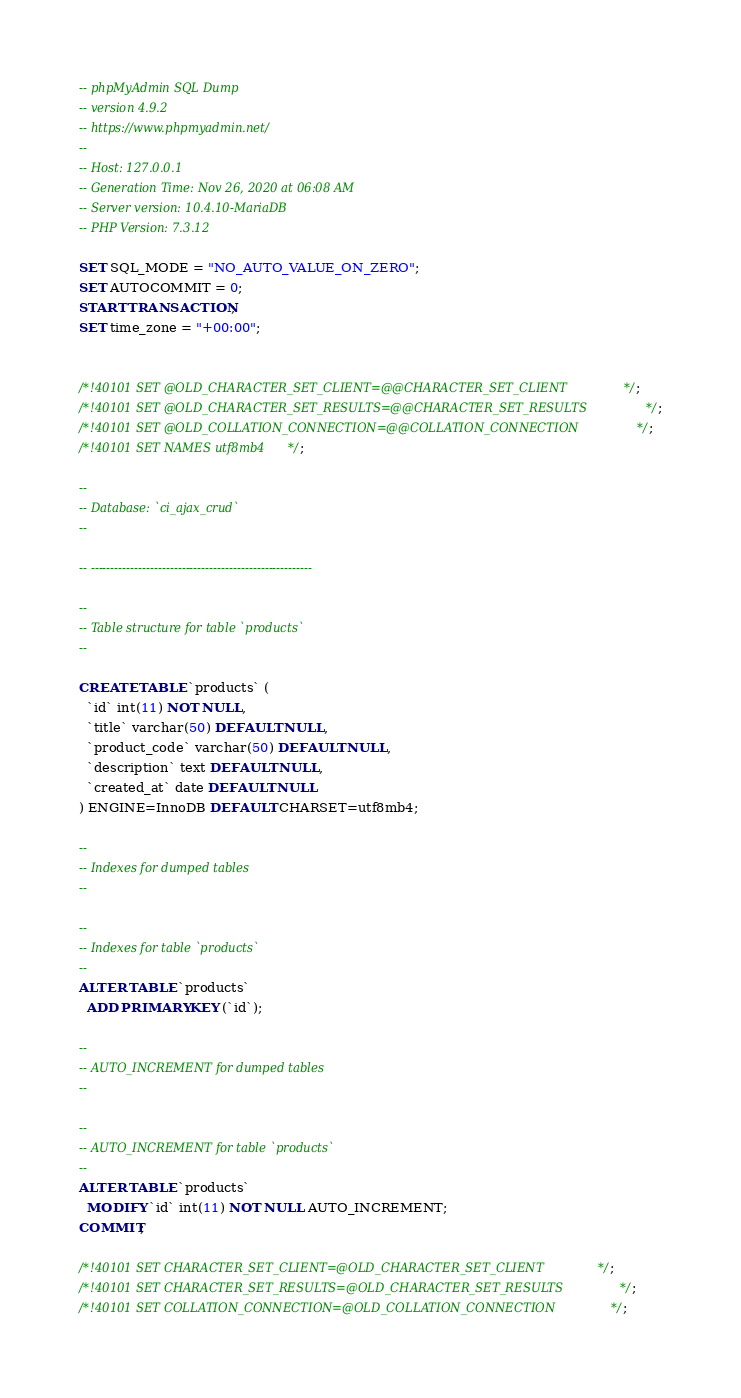Convert code to text. <code><loc_0><loc_0><loc_500><loc_500><_SQL_>-- phpMyAdmin SQL Dump
-- version 4.9.2
-- https://www.phpmyadmin.net/
--
-- Host: 127.0.0.1
-- Generation Time: Nov 26, 2020 at 06:08 AM
-- Server version: 10.4.10-MariaDB
-- PHP Version: 7.3.12

SET SQL_MODE = "NO_AUTO_VALUE_ON_ZERO";
SET AUTOCOMMIT = 0;
START TRANSACTION;
SET time_zone = "+00:00";


/*!40101 SET @OLD_CHARACTER_SET_CLIENT=@@CHARACTER_SET_CLIENT */;
/*!40101 SET @OLD_CHARACTER_SET_RESULTS=@@CHARACTER_SET_RESULTS */;
/*!40101 SET @OLD_COLLATION_CONNECTION=@@COLLATION_CONNECTION */;
/*!40101 SET NAMES utf8mb4 */;

--
-- Database: `ci_ajax_crud`
--

-- --------------------------------------------------------

--
-- Table structure for table `products`
--

CREATE TABLE `products` (
  `id` int(11) NOT NULL,
  `title` varchar(50) DEFAULT NULL,
  `product_code` varchar(50) DEFAULT NULL,
  `description` text DEFAULT NULL,
  `created_at` date DEFAULT NULL
) ENGINE=InnoDB DEFAULT CHARSET=utf8mb4;

--
-- Indexes for dumped tables
--

--
-- Indexes for table `products`
--
ALTER TABLE `products`
  ADD PRIMARY KEY (`id`);

--
-- AUTO_INCREMENT for dumped tables
--

--
-- AUTO_INCREMENT for table `products`
--
ALTER TABLE `products`
  MODIFY `id` int(11) NOT NULL AUTO_INCREMENT;
COMMIT;

/*!40101 SET CHARACTER_SET_CLIENT=@OLD_CHARACTER_SET_CLIENT */;
/*!40101 SET CHARACTER_SET_RESULTS=@OLD_CHARACTER_SET_RESULTS */;
/*!40101 SET COLLATION_CONNECTION=@OLD_COLLATION_CONNECTION */;
</code> 